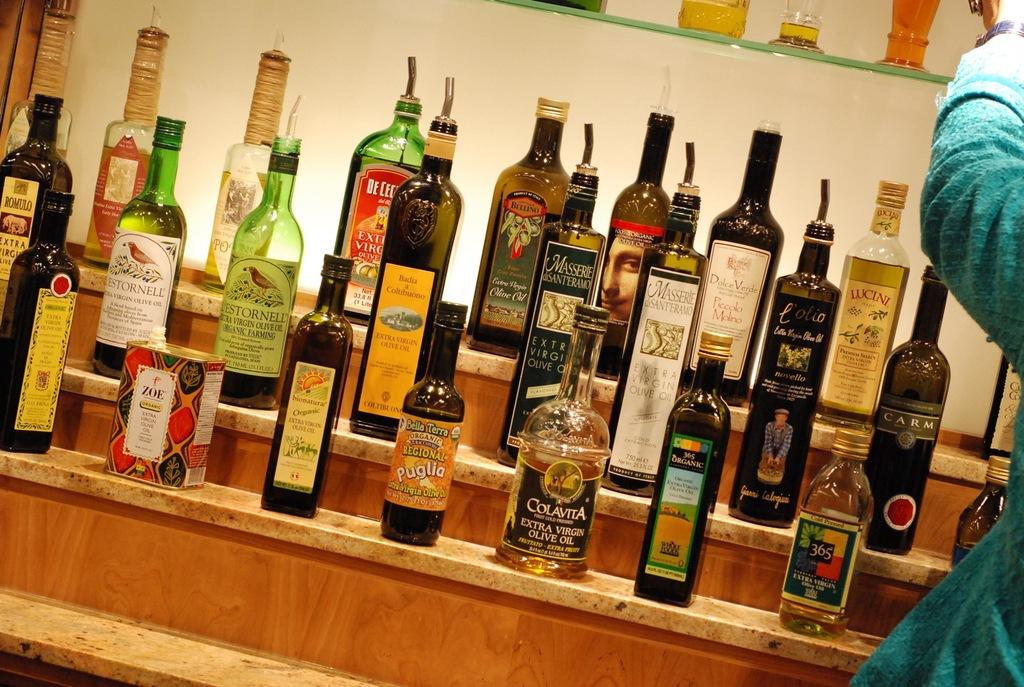<image>
Render a clear and concise summary of the photo. wooden shelves with bottles of olive oil such as 365 organic, colavita, bella terra, etc 